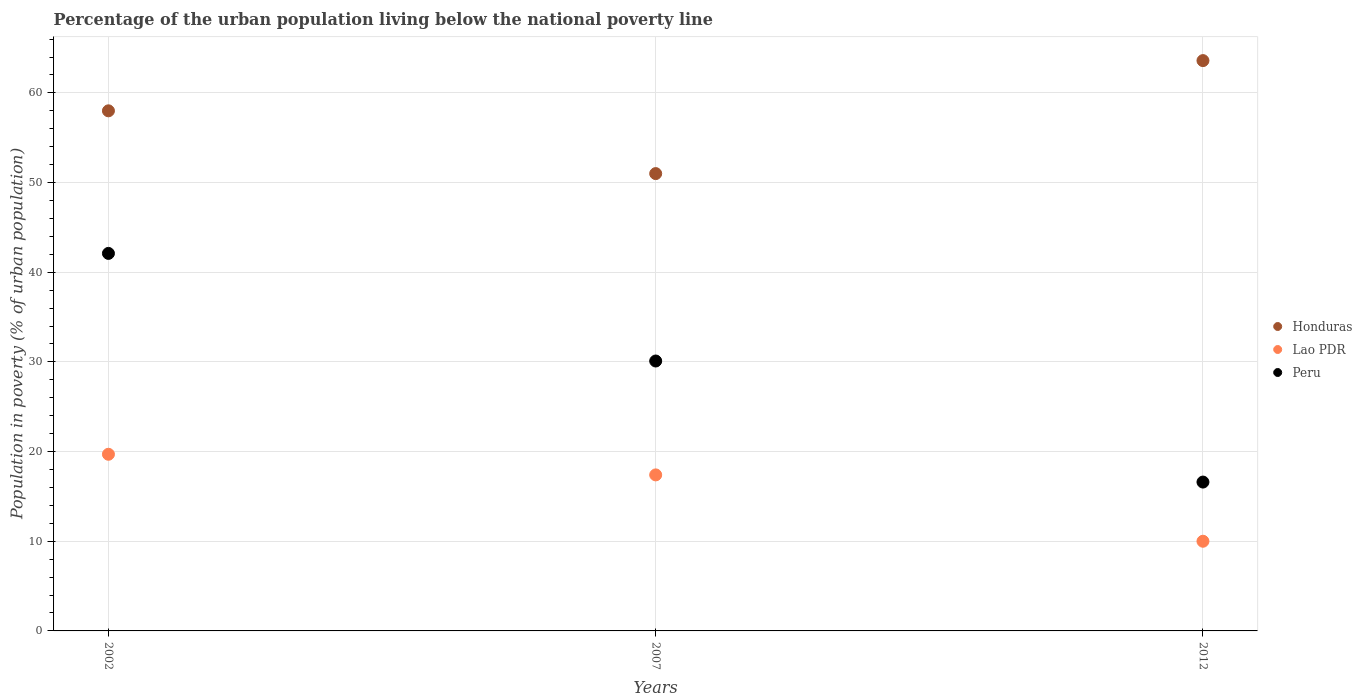What is the percentage of the urban population living below the national poverty line in Lao PDR in 2007?
Offer a very short reply. 17.4. Across all years, what is the maximum percentage of the urban population living below the national poverty line in Honduras?
Offer a very short reply. 63.6. Across all years, what is the minimum percentage of the urban population living below the national poverty line in Lao PDR?
Give a very brief answer. 10. In which year was the percentage of the urban population living below the national poverty line in Honduras minimum?
Ensure brevity in your answer.  2007. What is the total percentage of the urban population living below the national poverty line in Peru in the graph?
Your answer should be very brief. 88.8. What is the difference between the percentage of the urban population living below the national poverty line in Peru in 2002 and that in 2007?
Your answer should be compact. 12. What is the difference between the percentage of the urban population living below the national poverty line in Honduras in 2007 and the percentage of the urban population living below the national poverty line in Peru in 2012?
Provide a short and direct response. 34.4. What is the average percentage of the urban population living below the national poverty line in Peru per year?
Keep it short and to the point. 29.6. In the year 2007, what is the difference between the percentage of the urban population living below the national poverty line in Honduras and percentage of the urban population living below the national poverty line in Lao PDR?
Your response must be concise. 33.6. In how many years, is the percentage of the urban population living below the national poverty line in Peru greater than 58 %?
Offer a terse response. 0. What is the ratio of the percentage of the urban population living below the national poverty line in Peru in 2002 to that in 2007?
Your answer should be very brief. 1.4. Is the percentage of the urban population living below the national poverty line in Peru in 2002 less than that in 2007?
Offer a very short reply. No. What is the difference between the highest and the second highest percentage of the urban population living below the national poverty line in Lao PDR?
Your answer should be compact. 2.3. Is the sum of the percentage of the urban population living below the national poverty line in Lao PDR in 2002 and 2007 greater than the maximum percentage of the urban population living below the national poverty line in Honduras across all years?
Give a very brief answer. No. Is it the case that in every year, the sum of the percentage of the urban population living below the national poverty line in Peru and percentage of the urban population living below the national poverty line in Lao PDR  is greater than the percentage of the urban population living below the national poverty line in Honduras?
Your answer should be very brief. No. Is the percentage of the urban population living below the national poverty line in Honduras strictly less than the percentage of the urban population living below the national poverty line in Lao PDR over the years?
Make the answer very short. No. What is the difference between two consecutive major ticks on the Y-axis?
Give a very brief answer. 10. Are the values on the major ticks of Y-axis written in scientific E-notation?
Your answer should be compact. No. How are the legend labels stacked?
Provide a succinct answer. Vertical. What is the title of the graph?
Ensure brevity in your answer.  Percentage of the urban population living below the national poverty line. Does "Saudi Arabia" appear as one of the legend labels in the graph?
Offer a terse response. No. What is the label or title of the Y-axis?
Give a very brief answer. Population in poverty (% of urban population). What is the Population in poverty (% of urban population) of Lao PDR in 2002?
Offer a terse response. 19.7. What is the Population in poverty (% of urban population) in Peru in 2002?
Provide a short and direct response. 42.1. What is the Population in poverty (% of urban population) in Honduras in 2007?
Your response must be concise. 51. What is the Population in poverty (% of urban population) in Peru in 2007?
Make the answer very short. 30.1. What is the Population in poverty (% of urban population) in Honduras in 2012?
Your answer should be compact. 63.6. What is the Population in poverty (% of urban population) of Peru in 2012?
Ensure brevity in your answer.  16.6. Across all years, what is the maximum Population in poverty (% of urban population) of Honduras?
Your answer should be very brief. 63.6. Across all years, what is the maximum Population in poverty (% of urban population) in Lao PDR?
Make the answer very short. 19.7. Across all years, what is the maximum Population in poverty (% of urban population) of Peru?
Give a very brief answer. 42.1. What is the total Population in poverty (% of urban population) of Honduras in the graph?
Your answer should be compact. 172.6. What is the total Population in poverty (% of urban population) in Lao PDR in the graph?
Offer a very short reply. 47.1. What is the total Population in poverty (% of urban population) of Peru in the graph?
Ensure brevity in your answer.  88.8. What is the difference between the Population in poverty (% of urban population) of Honduras in 2002 and that in 2007?
Keep it short and to the point. 7. What is the difference between the Population in poverty (% of urban population) in Lao PDR in 2002 and that in 2007?
Your answer should be very brief. 2.3. What is the difference between the Population in poverty (% of urban population) of Lao PDR in 2007 and that in 2012?
Your answer should be compact. 7.4. What is the difference between the Population in poverty (% of urban population) in Honduras in 2002 and the Population in poverty (% of urban population) in Lao PDR in 2007?
Your answer should be compact. 40.6. What is the difference between the Population in poverty (% of urban population) in Honduras in 2002 and the Population in poverty (% of urban population) in Peru in 2007?
Offer a terse response. 27.9. What is the difference between the Population in poverty (% of urban population) of Lao PDR in 2002 and the Population in poverty (% of urban population) of Peru in 2007?
Your response must be concise. -10.4. What is the difference between the Population in poverty (% of urban population) in Honduras in 2002 and the Population in poverty (% of urban population) in Peru in 2012?
Ensure brevity in your answer.  41.4. What is the difference between the Population in poverty (% of urban population) in Lao PDR in 2002 and the Population in poverty (% of urban population) in Peru in 2012?
Provide a succinct answer. 3.1. What is the difference between the Population in poverty (% of urban population) of Honduras in 2007 and the Population in poverty (% of urban population) of Lao PDR in 2012?
Give a very brief answer. 41. What is the difference between the Population in poverty (% of urban population) of Honduras in 2007 and the Population in poverty (% of urban population) of Peru in 2012?
Offer a terse response. 34.4. What is the average Population in poverty (% of urban population) in Honduras per year?
Make the answer very short. 57.53. What is the average Population in poverty (% of urban population) of Peru per year?
Ensure brevity in your answer.  29.6. In the year 2002, what is the difference between the Population in poverty (% of urban population) of Honduras and Population in poverty (% of urban population) of Lao PDR?
Your answer should be very brief. 38.3. In the year 2002, what is the difference between the Population in poverty (% of urban population) of Lao PDR and Population in poverty (% of urban population) of Peru?
Your response must be concise. -22.4. In the year 2007, what is the difference between the Population in poverty (% of urban population) of Honduras and Population in poverty (% of urban population) of Lao PDR?
Provide a succinct answer. 33.6. In the year 2007, what is the difference between the Population in poverty (% of urban population) of Honduras and Population in poverty (% of urban population) of Peru?
Your answer should be compact. 20.9. In the year 2007, what is the difference between the Population in poverty (% of urban population) in Lao PDR and Population in poverty (% of urban population) in Peru?
Ensure brevity in your answer.  -12.7. In the year 2012, what is the difference between the Population in poverty (% of urban population) of Honduras and Population in poverty (% of urban population) of Lao PDR?
Give a very brief answer. 53.6. In the year 2012, what is the difference between the Population in poverty (% of urban population) of Lao PDR and Population in poverty (% of urban population) of Peru?
Ensure brevity in your answer.  -6.6. What is the ratio of the Population in poverty (% of urban population) of Honduras in 2002 to that in 2007?
Provide a short and direct response. 1.14. What is the ratio of the Population in poverty (% of urban population) in Lao PDR in 2002 to that in 2007?
Your answer should be compact. 1.13. What is the ratio of the Population in poverty (% of urban population) in Peru in 2002 to that in 2007?
Offer a very short reply. 1.4. What is the ratio of the Population in poverty (% of urban population) of Honduras in 2002 to that in 2012?
Offer a very short reply. 0.91. What is the ratio of the Population in poverty (% of urban population) in Lao PDR in 2002 to that in 2012?
Your response must be concise. 1.97. What is the ratio of the Population in poverty (% of urban population) of Peru in 2002 to that in 2012?
Offer a terse response. 2.54. What is the ratio of the Population in poverty (% of urban population) in Honduras in 2007 to that in 2012?
Make the answer very short. 0.8. What is the ratio of the Population in poverty (% of urban population) of Lao PDR in 2007 to that in 2012?
Give a very brief answer. 1.74. What is the ratio of the Population in poverty (% of urban population) in Peru in 2007 to that in 2012?
Provide a succinct answer. 1.81. What is the difference between the highest and the second highest Population in poverty (% of urban population) of Honduras?
Give a very brief answer. 5.6. What is the difference between the highest and the second highest Population in poverty (% of urban population) of Lao PDR?
Offer a terse response. 2.3. 